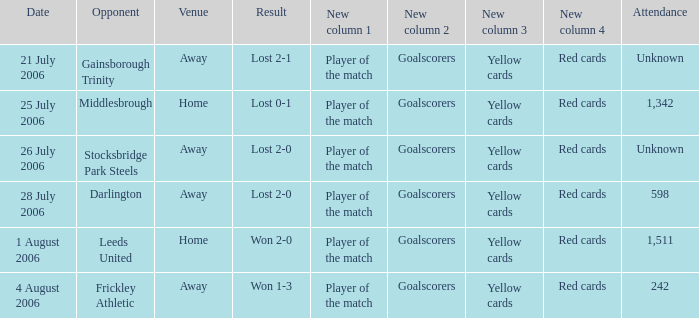What is the attendance rate for the Middlesbrough opponent? 1342.0. 